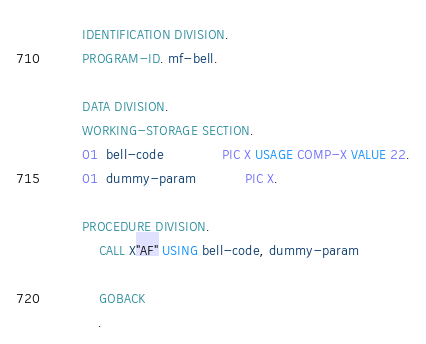<code> <loc_0><loc_0><loc_500><loc_500><_COBOL_>       IDENTIFICATION DIVISION.
       PROGRAM-ID. mf-bell.

       DATA DIVISION.
       WORKING-STORAGE SECTION.
       01  bell-code              PIC X USAGE COMP-X VALUE 22.
       01  dummy-param            PIC X.

       PROCEDURE DIVISION.
           CALL X"AF" USING bell-code, dummy-param

           GOBACK
           .
</code> 